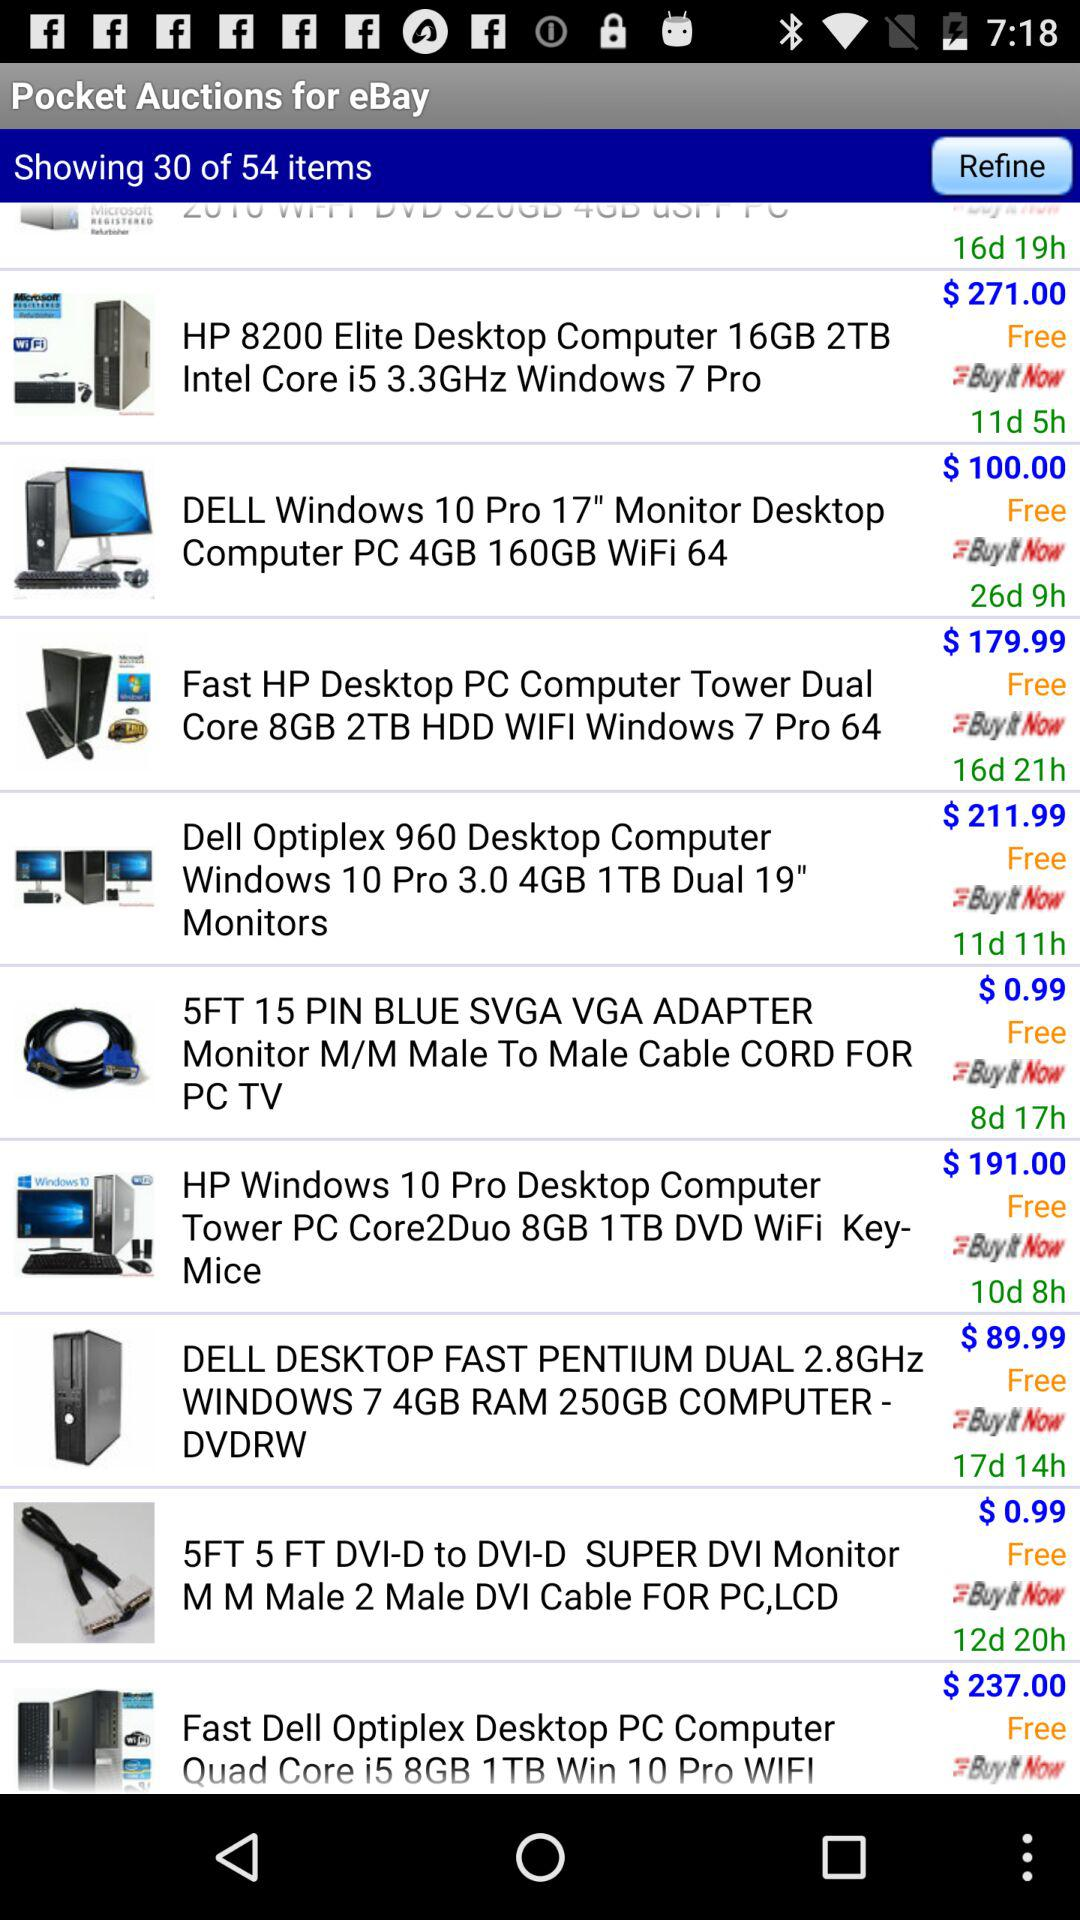How many items are shown on the screen? There are 54 items. 